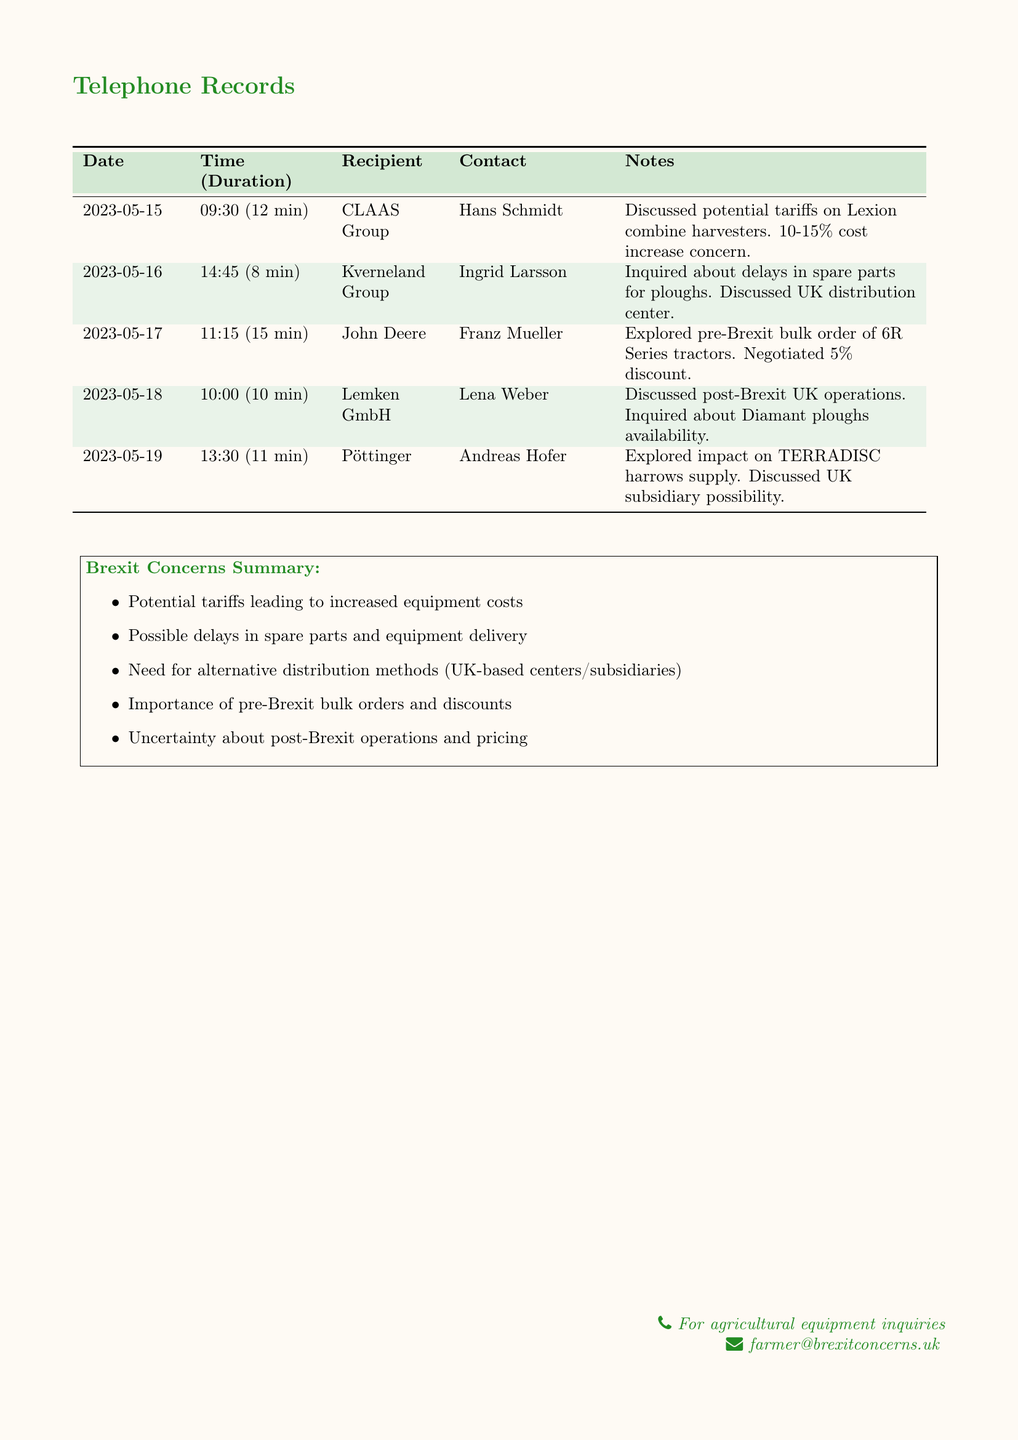What is the date of the call with CLAAS Group? The date of the call can be found in the records table under the CLAAS Group entry.
Answer: 2023-05-15 Who was contacted at Kverneland Group? The recipient's name can be found in the records table alongside the corresponding organization.
Answer: Ingrid Larsson What percentage increase in cost was discussed for Lexion combine harvesters? The specific percentage increase mentioned during the call with CLAAS Group is noted in the document.
Answer: 10-15% How long was the conversation with John Deere? The duration of the call can be found in the records table directly next to the call date.
Answer: 15 min What equipment was discussed regarding delays during the call with Kverneland Group? The specific equipment referred to during the conversation can be located in the notes section of the corresponding entry.
Answer: Spare parts for ploughs What was negotiated in the call with John Deere? The details about what was negotiated can be found under the notes for that call in the table.
Answer: 5% discount What is a key concern noted in the Brexit Concerns Summary? The summary lists various concerns that reflect the overall worries discussed in the calls.
Answer: Increased equipment costs Which company did the farmer discuss UK operations with? The entry in the document provides the company name connected to the discussion about UK operations.
Answer: Lemken GmbH What potential impact was explored concerning TERRADISC harrows? The exploration of impact is documented under the notes for the call with Pöttinger.
Answer: Supply impact 